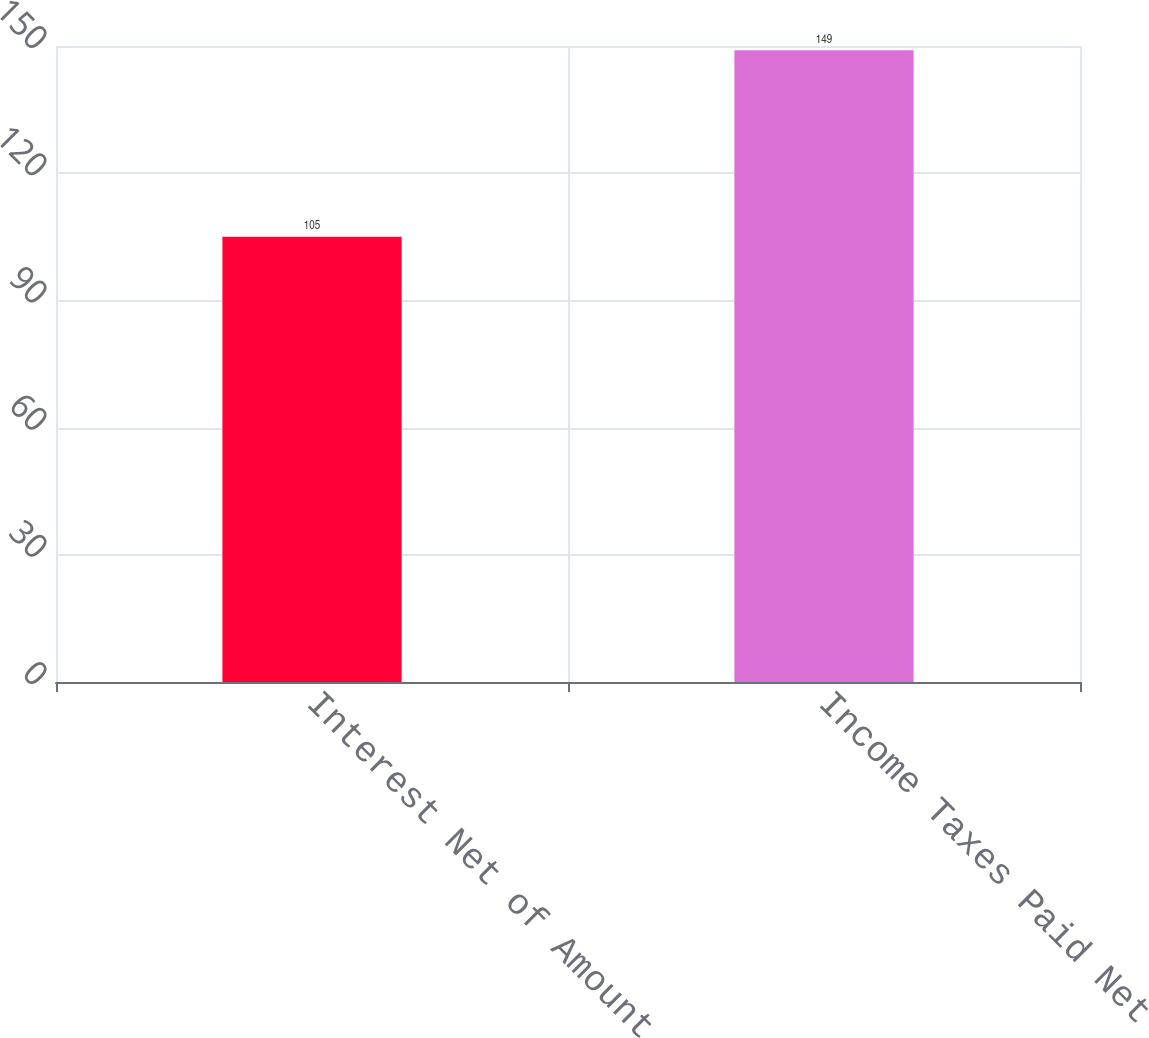Convert chart to OTSL. <chart><loc_0><loc_0><loc_500><loc_500><bar_chart><fcel>Interest Net of Amount<fcel>Income Taxes Paid Net<nl><fcel>105<fcel>149<nl></chart> 